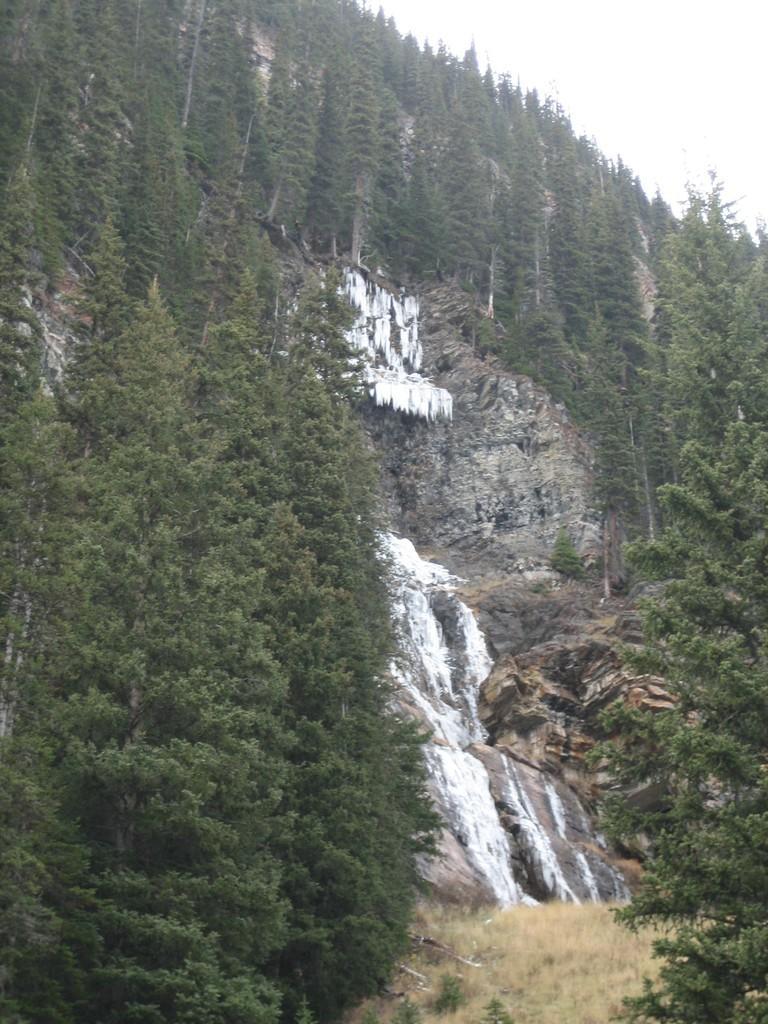How would you summarize this image in a sentence or two? Here we can see trees, plants, grass, water, and a mountain. In the background there is sky. 